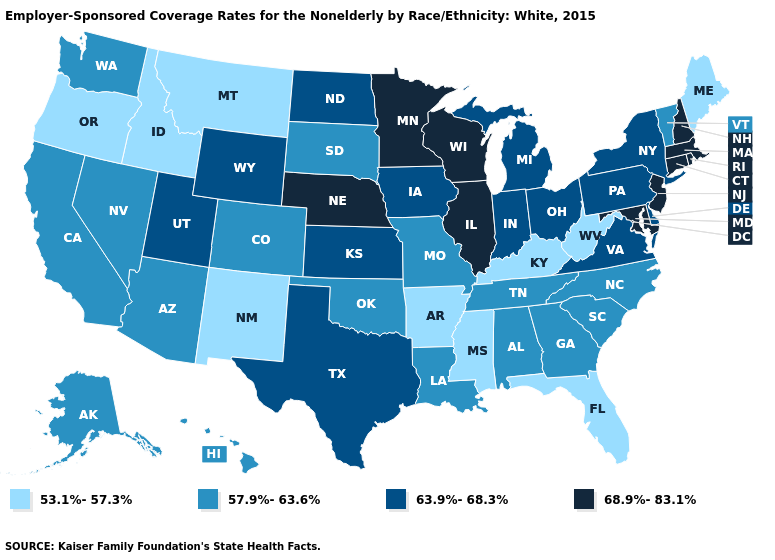What is the highest value in the USA?
Be succinct. 68.9%-83.1%. Name the states that have a value in the range 53.1%-57.3%?
Write a very short answer. Arkansas, Florida, Idaho, Kentucky, Maine, Mississippi, Montana, New Mexico, Oregon, West Virginia. What is the value of Montana?
Keep it brief. 53.1%-57.3%. Name the states that have a value in the range 57.9%-63.6%?
Quick response, please. Alabama, Alaska, Arizona, California, Colorado, Georgia, Hawaii, Louisiana, Missouri, Nevada, North Carolina, Oklahoma, South Carolina, South Dakota, Tennessee, Vermont, Washington. Among the states that border Minnesota , which have the lowest value?
Be succinct. South Dakota. What is the value of Alaska?
Concise answer only. 57.9%-63.6%. What is the value of South Dakota?
Concise answer only. 57.9%-63.6%. Name the states that have a value in the range 53.1%-57.3%?
Write a very short answer. Arkansas, Florida, Idaho, Kentucky, Maine, Mississippi, Montana, New Mexico, Oregon, West Virginia. What is the highest value in the MidWest ?
Quick response, please. 68.9%-83.1%. Which states hav the highest value in the Northeast?
Quick response, please. Connecticut, Massachusetts, New Hampshire, New Jersey, Rhode Island. Does the first symbol in the legend represent the smallest category?
Answer briefly. Yes. Name the states that have a value in the range 68.9%-83.1%?
Short answer required. Connecticut, Illinois, Maryland, Massachusetts, Minnesota, Nebraska, New Hampshire, New Jersey, Rhode Island, Wisconsin. What is the value of Iowa?
Concise answer only. 63.9%-68.3%. Which states have the highest value in the USA?
Quick response, please. Connecticut, Illinois, Maryland, Massachusetts, Minnesota, Nebraska, New Hampshire, New Jersey, Rhode Island, Wisconsin. What is the value of Florida?
Keep it brief. 53.1%-57.3%. 